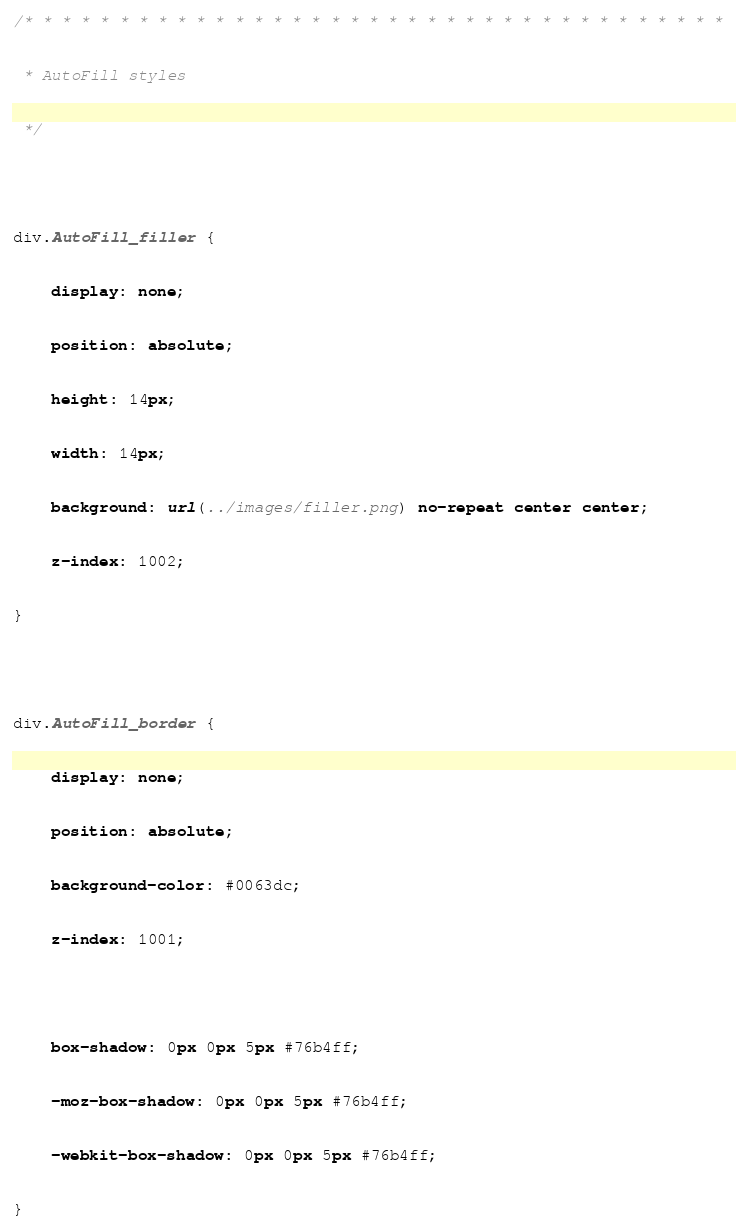<code> <loc_0><loc_0><loc_500><loc_500><_CSS_>/* * * * * * * * * * * * * * * * * * * * * * * * * * * * * * * * * * * * *
 * AutoFill styles
 */

div.AutoFill_filler {
	display: none;
	position: absolute;
	height: 14px;
	width: 14px;
	background: url(../images/filler.png) no-repeat center center;
	z-index: 1002;
}

div.AutoFill_border {
	display: none;
	position: absolute;
	background-color: #0063dc;
	z-index: 1001;
	
	box-shadow: 0px 0px 5px #76b4ff;
	-moz-box-shadow: 0px 0px 5px #76b4ff;
	-webkit-box-shadow: 0px 0px 5px #76b4ff;
}

</code> 